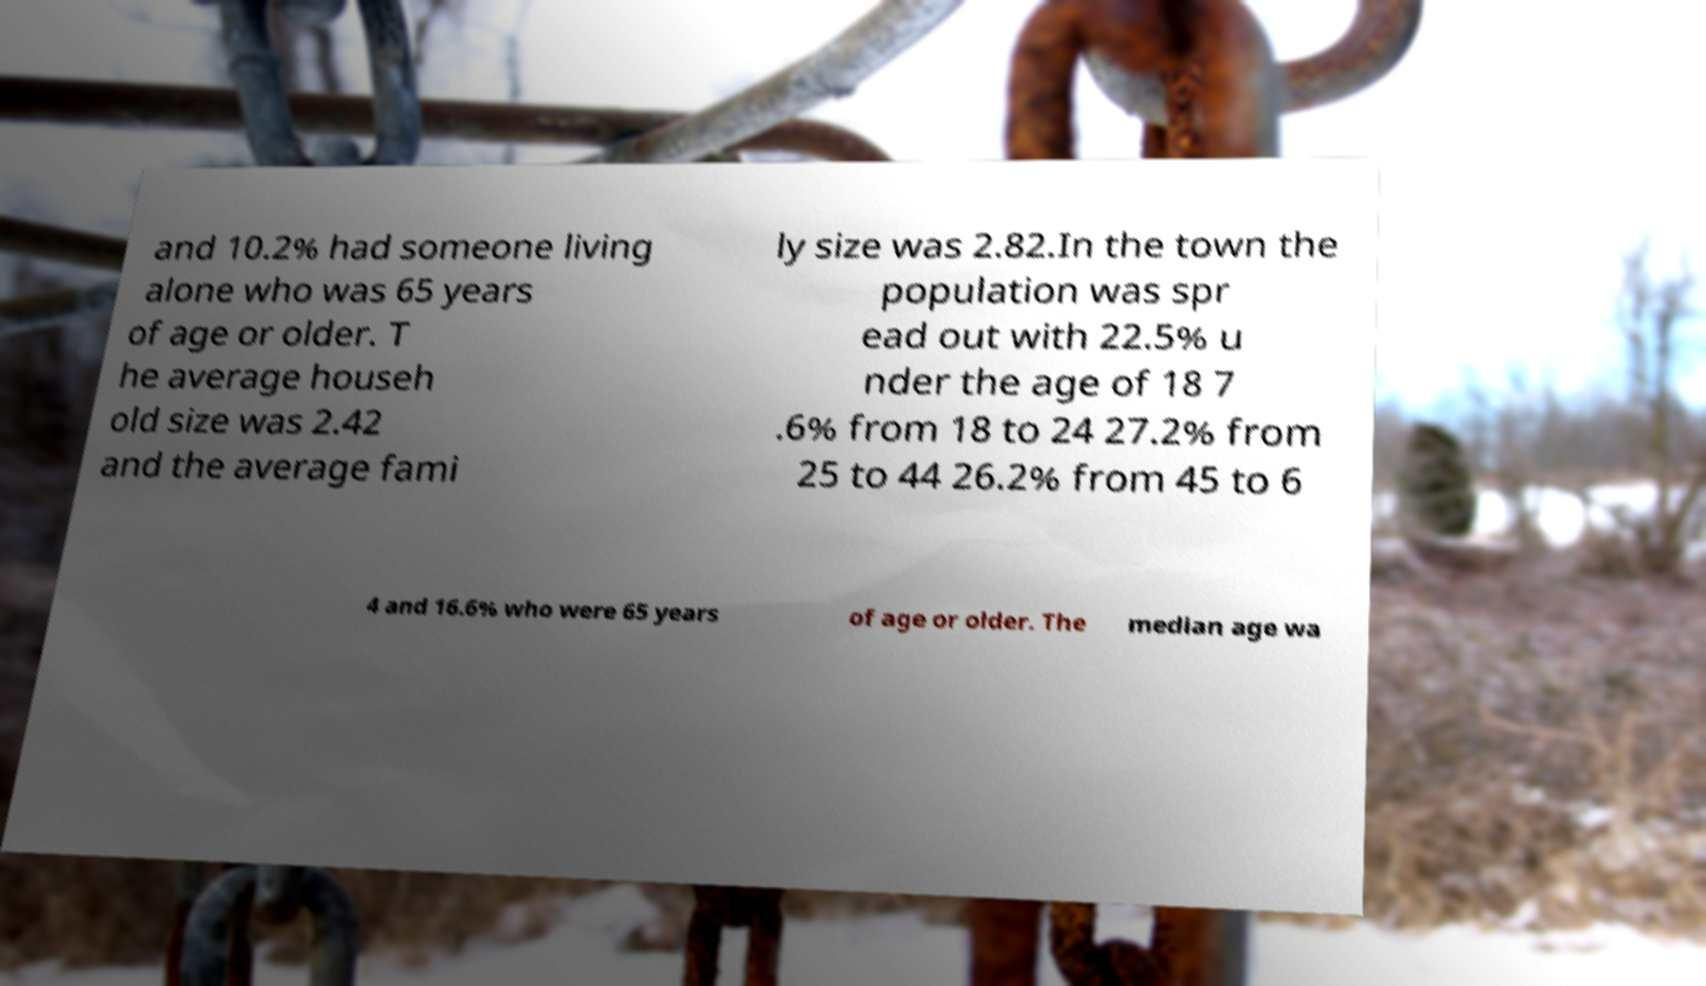Could you extract and type out the text from this image? and 10.2% had someone living alone who was 65 years of age or older. T he average househ old size was 2.42 and the average fami ly size was 2.82.In the town the population was spr ead out with 22.5% u nder the age of 18 7 .6% from 18 to 24 27.2% from 25 to 44 26.2% from 45 to 6 4 and 16.6% who were 65 years of age or older. The median age wa 